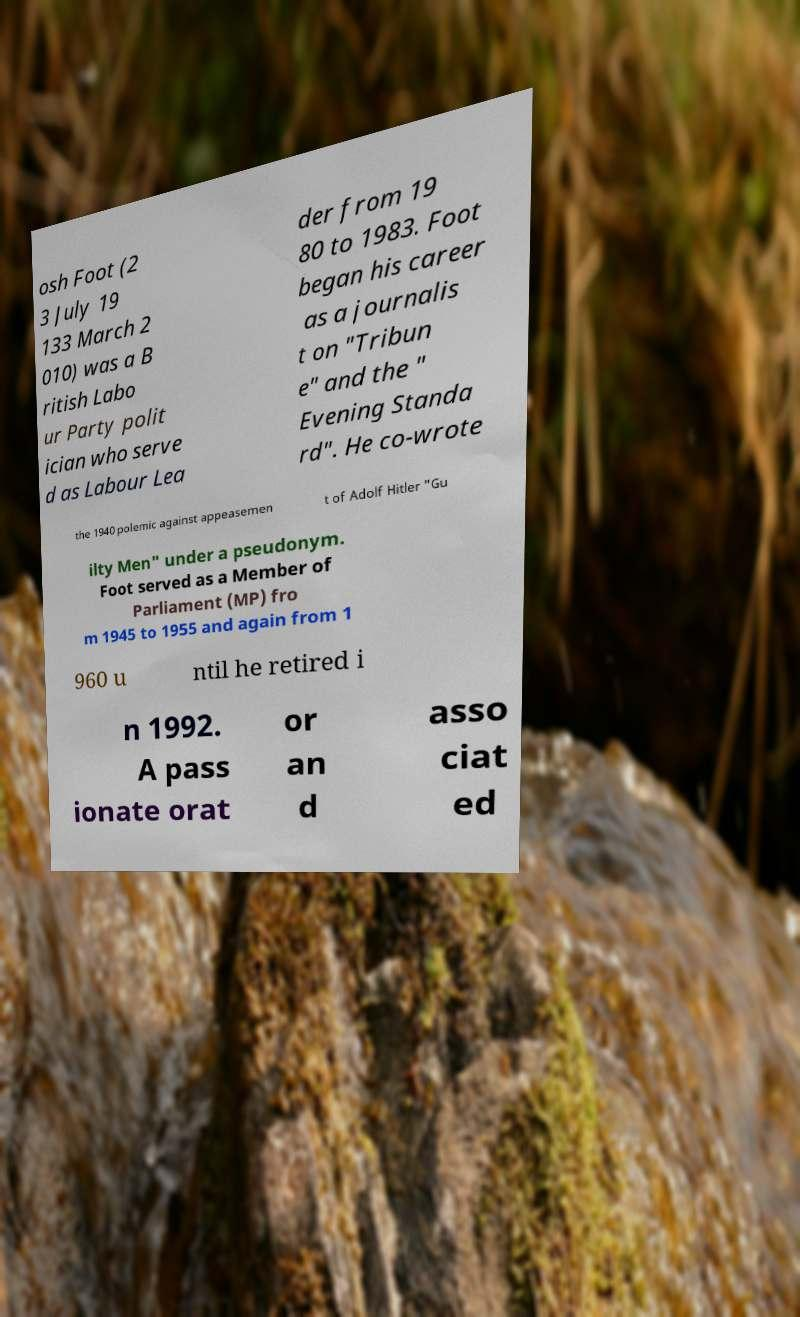What messages or text are displayed in this image? I need them in a readable, typed format. osh Foot (2 3 July 19 133 March 2 010) was a B ritish Labo ur Party polit ician who serve d as Labour Lea der from 19 80 to 1983. Foot began his career as a journalis t on "Tribun e" and the " Evening Standa rd". He co-wrote the 1940 polemic against appeasemen t of Adolf Hitler "Gu ilty Men" under a pseudonym. Foot served as a Member of Parliament (MP) fro m 1945 to 1955 and again from 1 960 u ntil he retired i n 1992. A pass ionate orat or an d asso ciat ed 